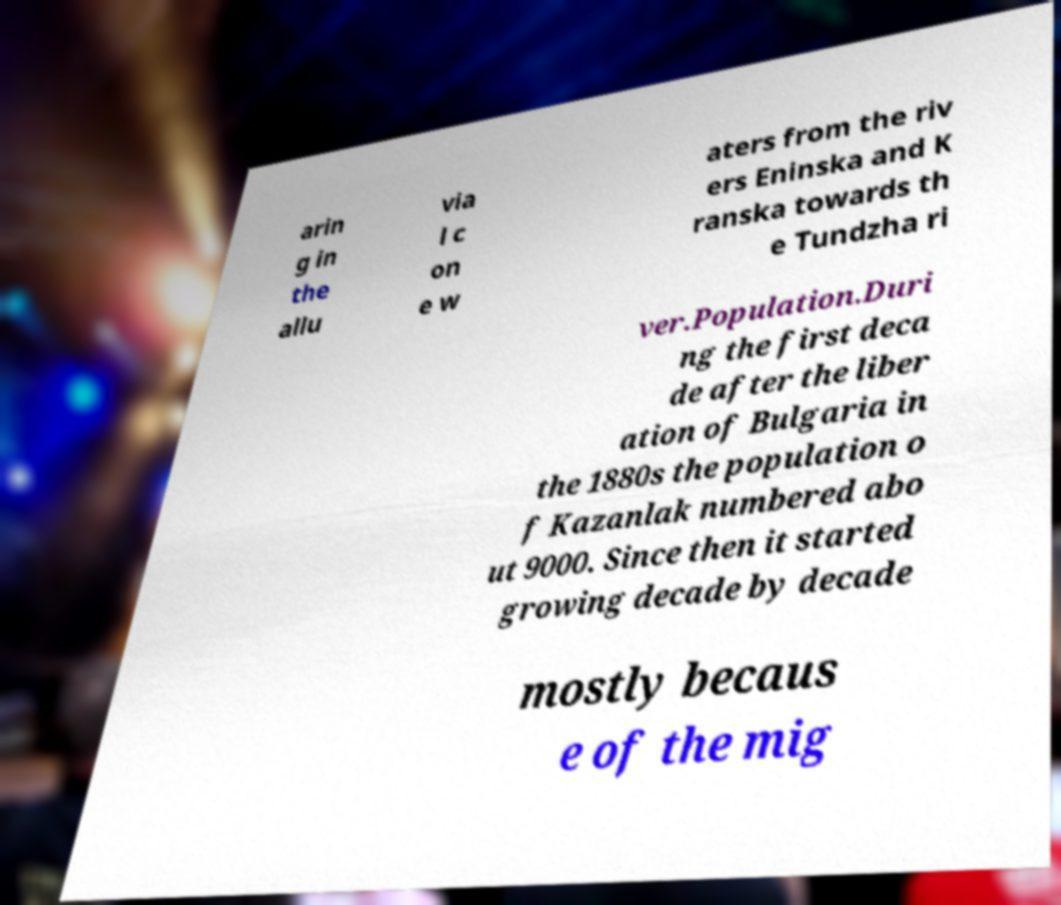Can you read and provide the text displayed in the image?This photo seems to have some interesting text. Can you extract and type it out for me? arin g in the allu via l c on e w aters from the riv ers Eninska and K ranska towards th e Tundzha ri ver.Population.Duri ng the first deca de after the liber ation of Bulgaria in the 1880s the population o f Kazanlak numbered abo ut 9000. Since then it started growing decade by decade mostly becaus e of the mig 